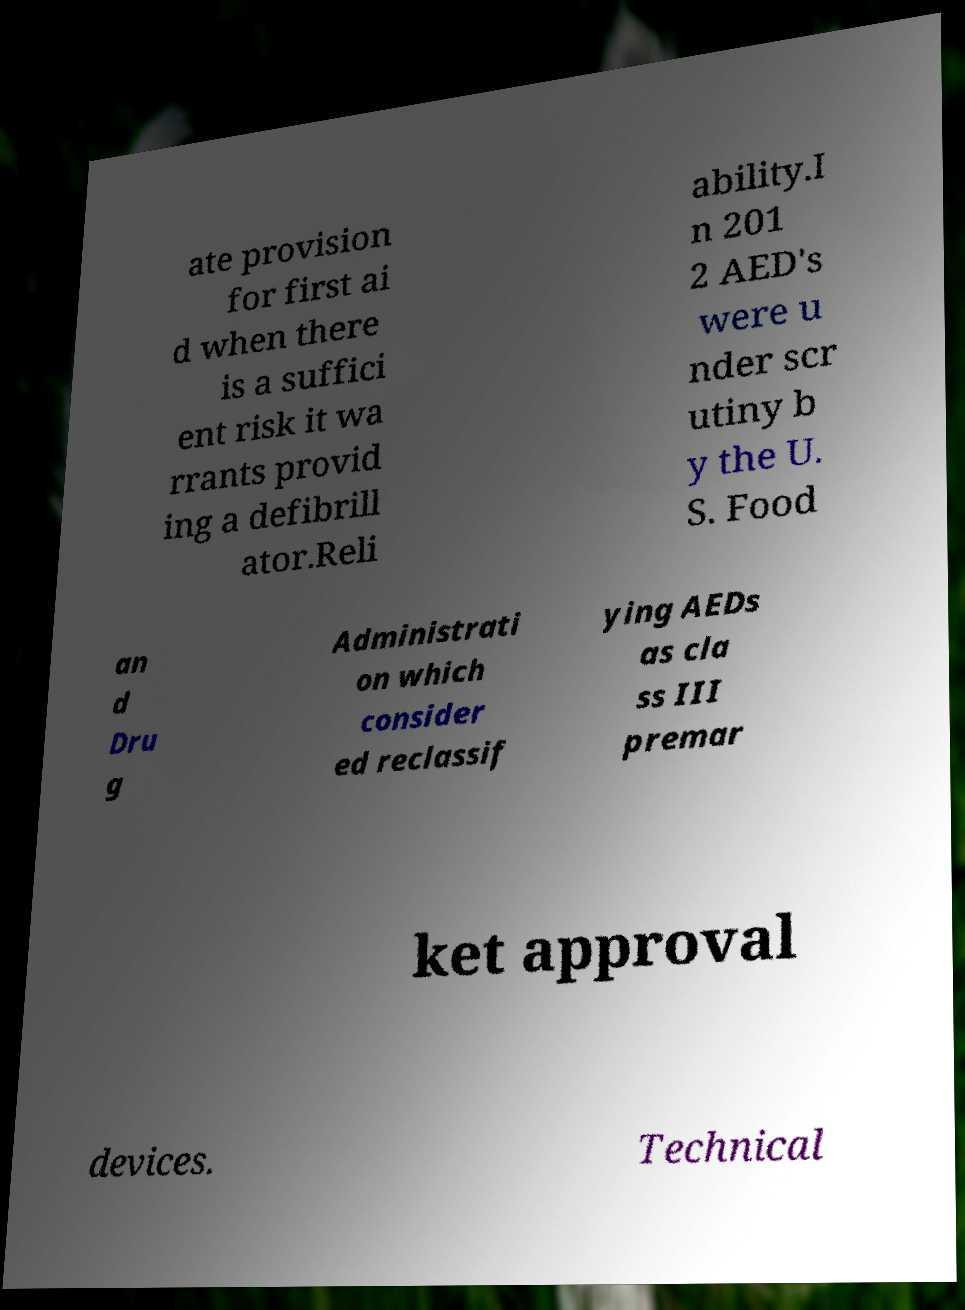Please identify and transcribe the text found in this image. ate provision for first ai d when there is a suffici ent risk it wa rrants provid ing a defibrill ator.Reli ability.I n 201 2 AED's were u nder scr utiny b y the U. S. Food an d Dru g Administrati on which consider ed reclassif ying AEDs as cla ss III premar ket approval devices. Technical 